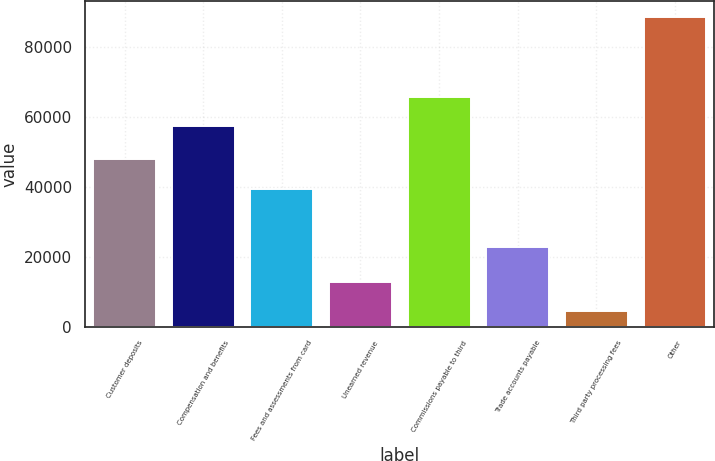Convert chart to OTSL. <chart><loc_0><loc_0><loc_500><loc_500><bar_chart><fcel>Customer deposits<fcel>Compensation and benefits<fcel>Fees and assessments from card<fcel>Unearned revenue<fcel>Commissions payable to third<fcel>Trade accounts payable<fcel>Third party processing fees<fcel>Other<nl><fcel>47844.7<fcel>57238<fcel>39417<fcel>12826.7<fcel>65665.7<fcel>22836<fcel>4399<fcel>88676<nl></chart> 